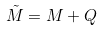Convert formula to latex. <formula><loc_0><loc_0><loc_500><loc_500>\tilde { M } = M + Q</formula> 